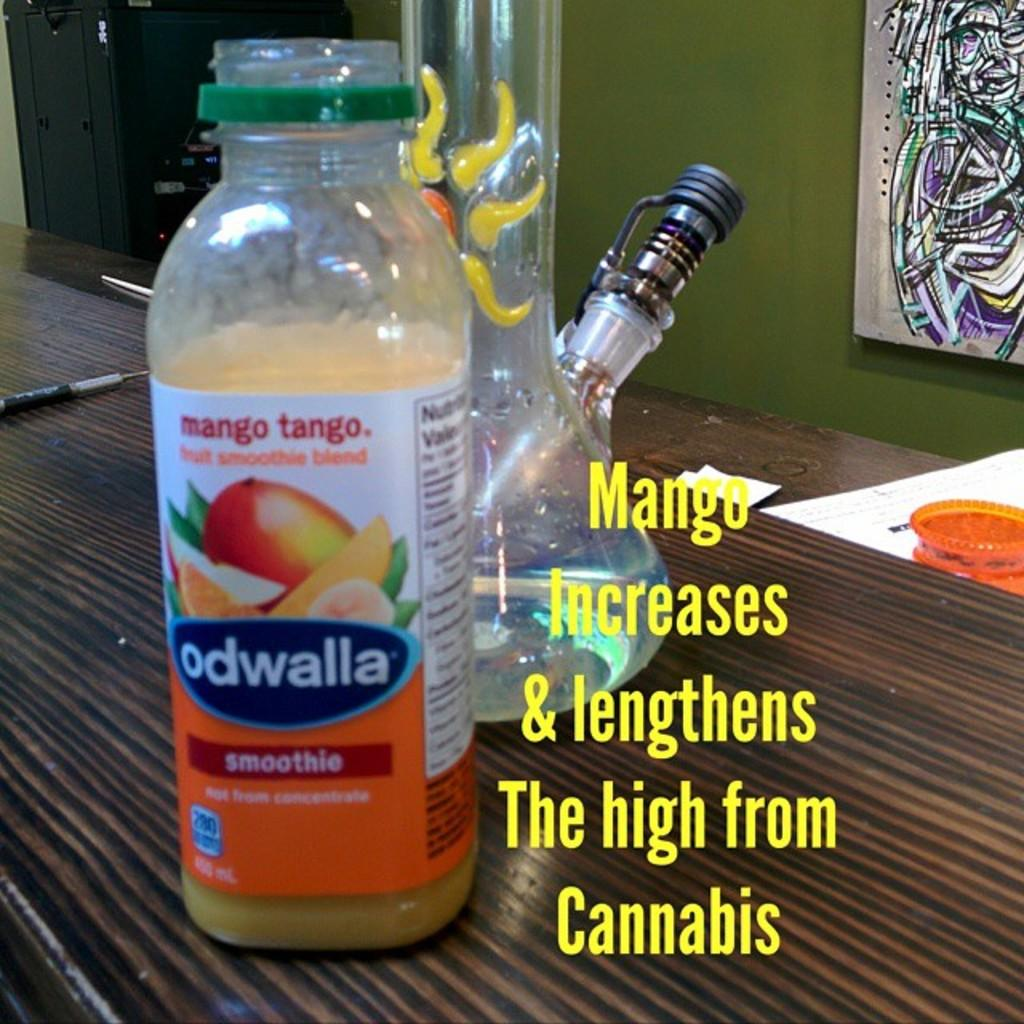<image>
Provide a brief description of the given image. Odwalla Smoothie Mango Tango that increases and lengths the high from Cannabis. 